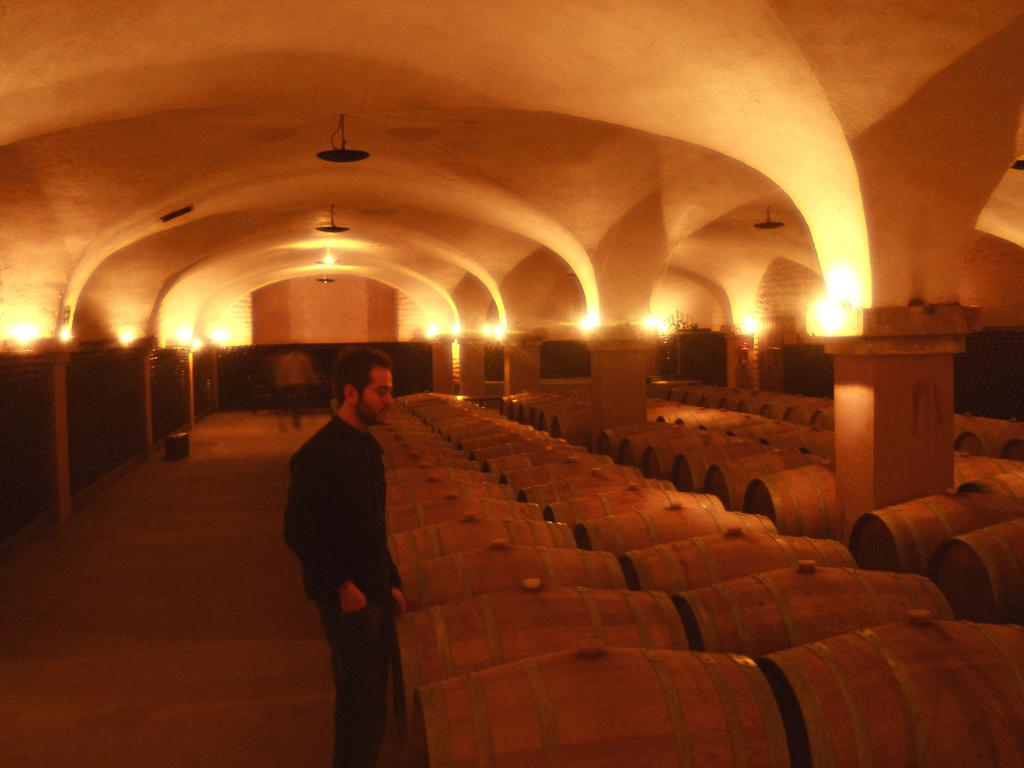What is the main subject in the image? There is a man standing in the image. What objects are present in the image besides the man? There are wooden barrels in the image. What can be seen on the ceiling in the image? There are lights on the ceiling in the image. What type of skin can be seen on the man's hands in the image? There is no specific detail about the man's skin visible in the image. Can you tell me how many pencils are on the man's desk in the image? There is no desk or pencils present in the image. 